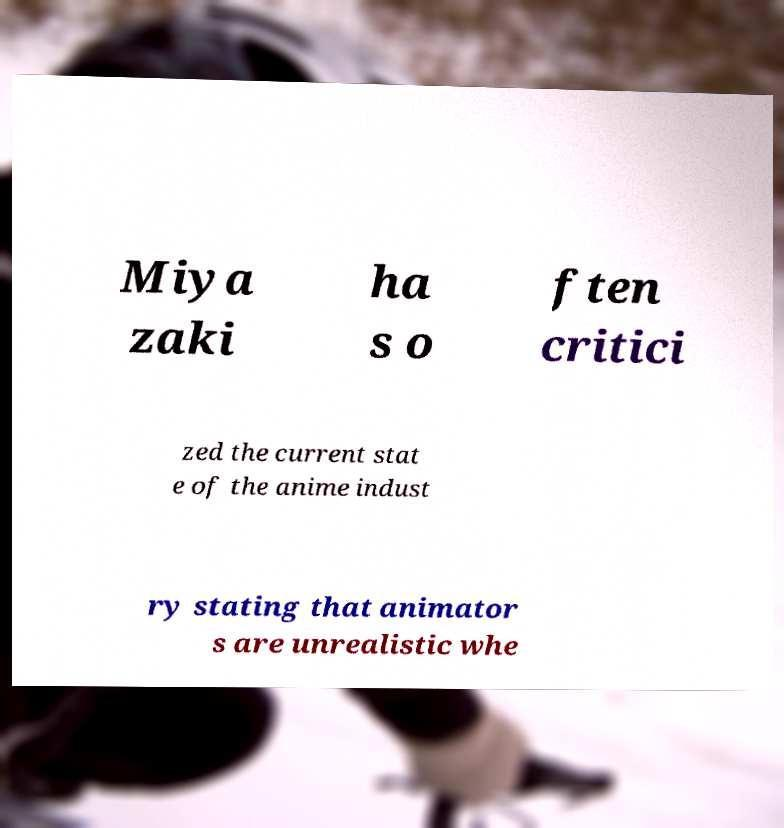Can you accurately transcribe the text from the provided image for me? Miya zaki ha s o ften critici zed the current stat e of the anime indust ry stating that animator s are unrealistic whe 